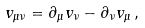<formula> <loc_0><loc_0><loc_500><loc_500>v _ { \mu \nu } = \partial _ { \mu } v _ { \nu } - \partial _ { \nu } v _ { \mu } \, ,</formula> 